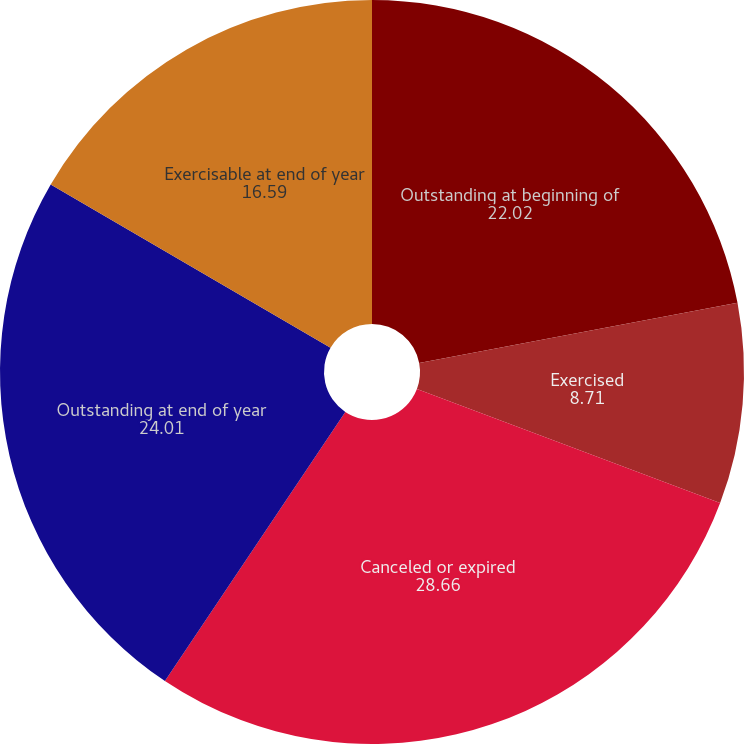<chart> <loc_0><loc_0><loc_500><loc_500><pie_chart><fcel>Outstanding at beginning of<fcel>Exercised<fcel>Canceled or expired<fcel>Outstanding at end of year<fcel>Exercisable at end of year<nl><fcel>22.02%<fcel>8.71%<fcel>28.66%<fcel>24.01%<fcel>16.59%<nl></chart> 